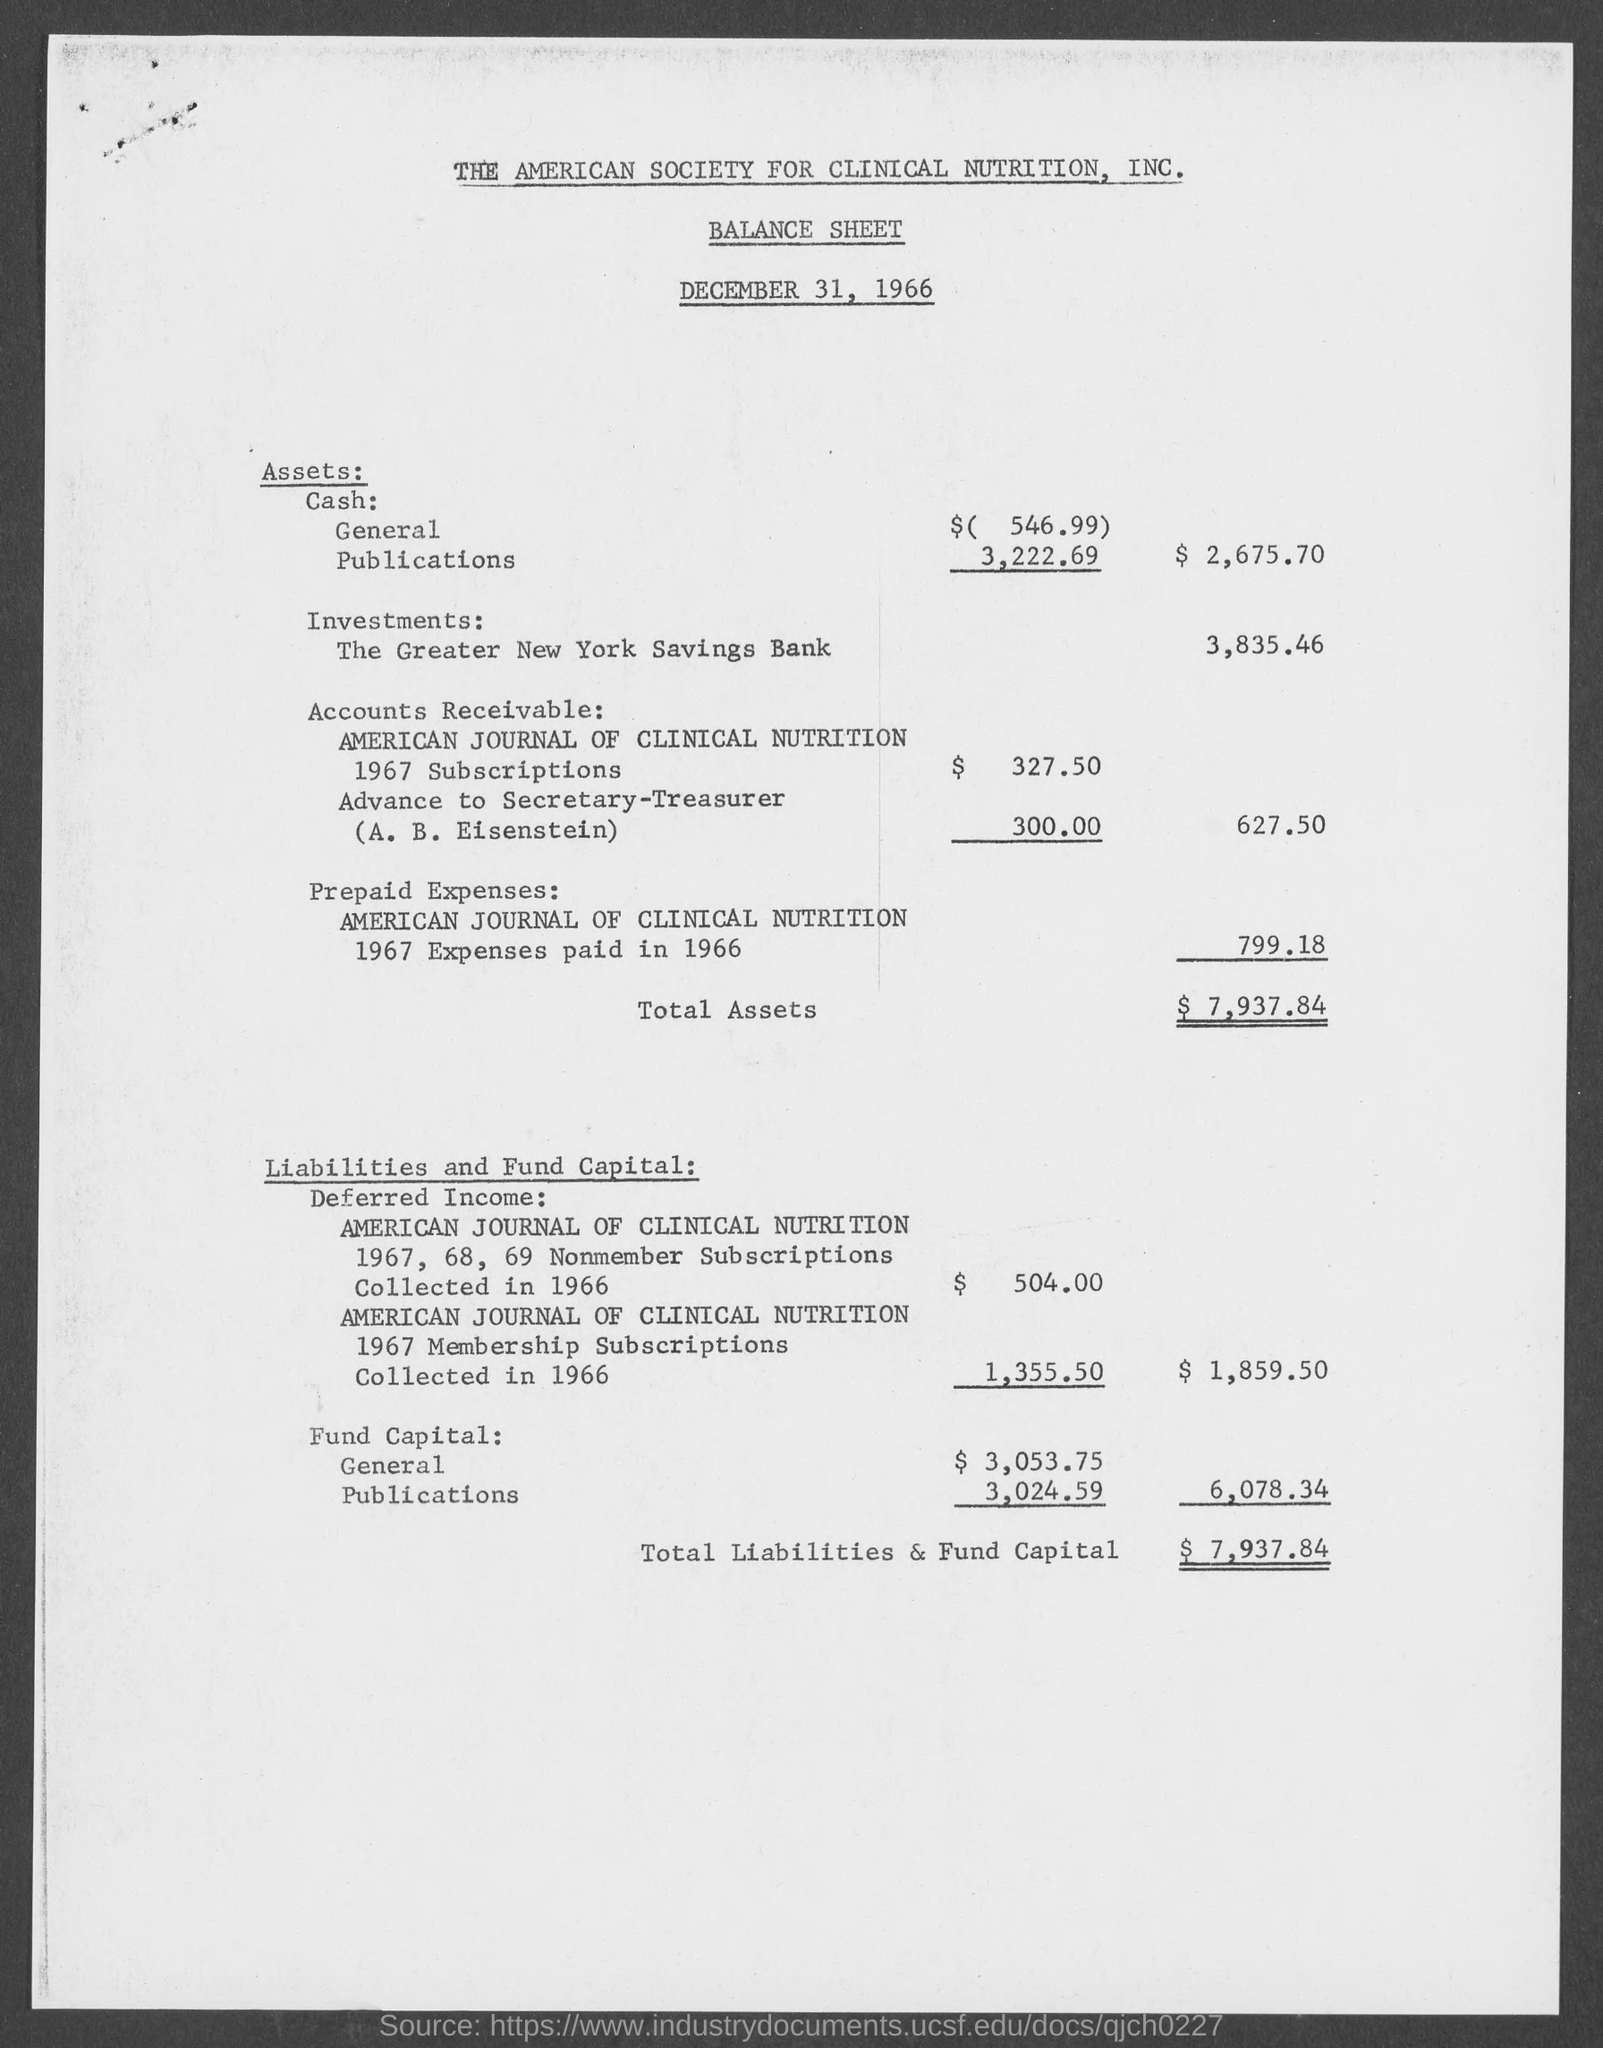Indicate a few pertinent items in this graphic. The balance sheet with a issued date of December 31, 1966, was issued on that date. The total assets listed in the balance sheet are $7,937.84. The amount of total liabilities and fund capital in the balance sheet is $7,937.84. 